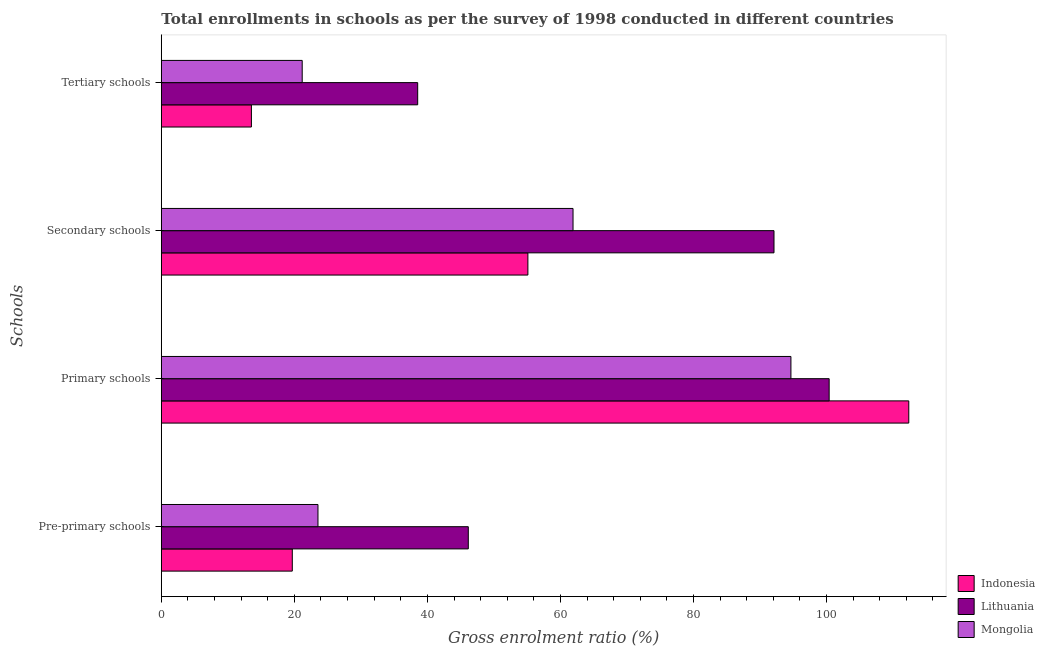How many different coloured bars are there?
Your answer should be compact. 3. How many groups of bars are there?
Your response must be concise. 4. Are the number of bars on each tick of the Y-axis equal?
Give a very brief answer. Yes. What is the label of the 3rd group of bars from the top?
Ensure brevity in your answer.  Primary schools. What is the gross enrolment ratio in primary schools in Mongolia?
Give a very brief answer. 94.65. Across all countries, what is the maximum gross enrolment ratio in secondary schools?
Make the answer very short. 92.11. Across all countries, what is the minimum gross enrolment ratio in secondary schools?
Provide a short and direct response. 55.11. In which country was the gross enrolment ratio in pre-primary schools minimum?
Your answer should be very brief. Indonesia. What is the total gross enrolment ratio in tertiary schools in the graph?
Offer a very short reply. 73.26. What is the difference between the gross enrolment ratio in tertiary schools in Lithuania and that in Indonesia?
Your response must be concise. 25. What is the difference between the gross enrolment ratio in secondary schools in Mongolia and the gross enrolment ratio in primary schools in Lithuania?
Offer a terse response. -38.5. What is the average gross enrolment ratio in primary schools per country?
Your response must be concise. 102.47. What is the difference between the gross enrolment ratio in primary schools and gross enrolment ratio in tertiary schools in Lithuania?
Your answer should be very brief. 61.86. What is the ratio of the gross enrolment ratio in pre-primary schools in Lithuania to that in Indonesia?
Ensure brevity in your answer.  2.34. Is the difference between the gross enrolment ratio in secondary schools in Indonesia and Mongolia greater than the difference between the gross enrolment ratio in pre-primary schools in Indonesia and Mongolia?
Offer a very short reply. No. What is the difference between the highest and the second highest gross enrolment ratio in tertiary schools?
Keep it short and to the point. 17.36. What is the difference between the highest and the lowest gross enrolment ratio in pre-primary schools?
Ensure brevity in your answer.  26.46. In how many countries, is the gross enrolment ratio in tertiary schools greater than the average gross enrolment ratio in tertiary schools taken over all countries?
Provide a short and direct response. 1. Is it the case that in every country, the sum of the gross enrolment ratio in tertiary schools and gross enrolment ratio in pre-primary schools is greater than the sum of gross enrolment ratio in primary schools and gross enrolment ratio in secondary schools?
Keep it short and to the point. No. What does the 2nd bar from the top in Secondary schools represents?
Ensure brevity in your answer.  Lithuania. What does the 2nd bar from the bottom in Secondary schools represents?
Keep it short and to the point. Lithuania. Are all the bars in the graph horizontal?
Ensure brevity in your answer.  Yes. What is the difference between two consecutive major ticks on the X-axis?
Your answer should be compact. 20. Does the graph contain any zero values?
Provide a short and direct response. No. Does the graph contain grids?
Your answer should be very brief. No. What is the title of the graph?
Provide a succinct answer. Total enrollments in schools as per the survey of 1998 conducted in different countries. Does "Middle East & North Africa (all income levels)" appear as one of the legend labels in the graph?
Make the answer very short. No. What is the label or title of the Y-axis?
Your answer should be compact. Schools. What is the Gross enrolment ratio (%) of Indonesia in Pre-primary schools?
Make the answer very short. 19.69. What is the Gross enrolment ratio (%) in Lithuania in Pre-primary schools?
Your answer should be compact. 46.15. What is the Gross enrolment ratio (%) of Mongolia in Pre-primary schools?
Provide a short and direct response. 23.55. What is the Gross enrolment ratio (%) of Indonesia in Primary schools?
Your response must be concise. 112.37. What is the Gross enrolment ratio (%) in Lithuania in Primary schools?
Give a very brief answer. 100.4. What is the Gross enrolment ratio (%) of Mongolia in Primary schools?
Offer a very short reply. 94.65. What is the Gross enrolment ratio (%) of Indonesia in Secondary schools?
Give a very brief answer. 55.11. What is the Gross enrolment ratio (%) of Lithuania in Secondary schools?
Ensure brevity in your answer.  92.11. What is the Gross enrolment ratio (%) in Mongolia in Secondary schools?
Provide a succinct answer. 61.89. What is the Gross enrolment ratio (%) in Indonesia in Tertiary schools?
Your answer should be very brief. 13.54. What is the Gross enrolment ratio (%) of Lithuania in Tertiary schools?
Make the answer very short. 38.54. What is the Gross enrolment ratio (%) in Mongolia in Tertiary schools?
Give a very brief answer. 21.18. Across all Schools, what is the maximum Gross enrolment ratio (%) in Indonesia?
Keep it short and to the point. 112.37. Across all Schools, what is the maximum Gross enrolment ratio (%) in Lithuania?
Provide a short and direct response. 100.4. Across all Schools, what is the maximum Gross enrolment ratio (%) of Mongolia?
Offer a very short reply. 94.65. Across all Schools, what is the minimum Gross enrolment ratio (%) of Indonesia?
Offer a very short reply. 13.54. Across all Schools, what is the minimum Gross enrolment ratio (%) of Lithuania?
Your answer should be very brief. 38.54. Across all Schools, what is the minimum Gross enrolment ratio (%) of Mongolia?
Your answer should be very brief. 21.18. What is the total Gross enrolment ratio (%) of Indonesia in the graph?
Provide a short and direct response. 200.71. What is the total Gross enrolment ratio (%) of Lithuania in the graph?
Give a very brief answer. 277.2. What is the total Gross enrolment ratio (%) of Mongolia in the graph?
Ensure brevity in your answer.  201.27. What is the difference between the Gross enrolment ratio (%) in Indonesia in Pre-primary schools and that in Primary schools?
Offer a very short reply. -92.68. What is the difference between the Gross enrolment ratio (%) in Lithuania in Pre-primary schools and that in Primary schools?
Offer a very short reply. -54.25. What is the difference between the Gross enrolment ratio (%) of Mongolia in Pre-primary schools and that in Primary schools?
Offer a very short reply. -71.1. What is the difference between the Gross enrolment ratio (%) in Indonesia in Pre-primary schools and that in Secondary schools?
Give a very brief answer. -35.42. What is the difference between the Gross enrolment ratio (%) in Lithuania in Pre-primary schools and that in Secondary schools?
Provide a short and direct response. -45.96. What is the difference between the Gross enrolment ratio (%) in Mongolia in Pre-primary schools and that in Secondary schools?
Keep it short and to the point. -38.35. What is the difference between the Gross enrolment ratio (%) in Indonesia in Pre-primary schools and that in Tertiary schools?
Your answer should be compact. 6.15. What is the difference between the Gross enrolment ratio (%) of Lithuania in Pre-primary schools and that in Tertiary schools?
Offer a very short reply. 7.61. What is the difference between the Gross enrolment ratio (%) in Mongolia in Pre-primary schools and that in Tertiary schools?
Your answer should be compact. 2.37. What is the difference between the Gross enrolment ratio (%) of Indonesia in Primary schools and that in Secondary schools?
Provide a succinct answer. 57.26. What is the difference between the Gross enrolment ratio (%) in Lithuania in Primary schools and that in Secondary schools?
Keep it short and to the point. 8.29. What is the difference between the Gross enrolment ratio (%) in Mongolia in Primary schools and that in Secondary schools?
Provide a short and direct response. 32.76. What is the difference between the Gross enrolment ratio (%) in Indonesia in Primary schools and that in Tertiary schools?
Your response must be concise. 98.82. What is the difference between the Gross enrolment ratio (%) in Lithuania in Primary schools and that in Tertiary schools?
Your answer should be very brief. 61.86. What is the difference between the Gross enrolment ratio (%) of Mongolia in Primary schools and that in Tertiary schools?
Ensure brevity in your answer.  73.47. What is the difference between the Gross enrolment ratio (%) in Indonesia in Secondary schools and that in Tertiary schools?
Provide a succinct answer. 41.56. What is the difference between the Gross enrolment ratio (%) in Lithuania in Secondary schools and that in Tertiary schools?
Offer a terse response. 53.56. What is the difference between the Gross enrolment ratio (%) of Mongolia in Secondary schools and that in Tertiary schools?
Offer a terse response. 40.72. What is the difference between the Gross enrolment ratio (%) in Indonesia in Pre-primary schools and the Gross enrolment ratio (%) in Lithuania in Primary schools?
Offer a very short reply. -80.71. What is the difference between the Gross enrolment ratio (%) in Indonesia in Pre-primary schools and the Gross enrolment ratio (%) in Mongolia in Primary schools?
Your answer should be compact. -74.96. What is the difference between the Gross enrolment ratio (%) of Lithuania in Pre-primary schools and the Gross enrolment ratio (%) of Mongolia in Primary schools?
Your response must be concise. -48.5. What is the difference between the Gross enrolment ratio (%) in Indonesia in Pre-primary schools and the Gross enrolment ratio (%) in Lithuania in Secondary schools?
Offer a terse response. -72.42. What is the difference between the Gross enrolment ratio (%) of Indonesia in Pre-primary schools and the Gross enrolment ratio (%) of Mongolia in Secondary schools?
Your response must be concise. -42.2. What is the difference between the Gross enrolment ratio (%) in Lithuania in Pre-primary schools and the Gross enrolment ratio (%) in Mongolia in Secondary schools?
Offer a very short reply. -15.74. What is the difference between the Gross enrolment ratio (%) of Indonesia in Pre-primary schools and the Gross enrolment ratio (%) of Lithuania in Tertiary schools?
Ensure brevity in your answer.  -18.85. What is the difference between the Gross enrolment ratio (%) in Indonesia in Pre-primary schools and the Gross enrolment ratio (%) in Mongolia in Tertiary schools?
Give a very brief answer. -1.49. What is the difference between the Gross enrolment ratio (%) of Lithuania in Pre-primary schools and the Gross enrolment ratio (%) of Mongolia in Tertiary schools?
Provide a succinct answer. 24.97. What is the difference between the Gross enrolment ratio (%) of Indonesia in Primary schools and the Gross enrolment ratio (%) of Lithuania in Secondary schools?
Give a very brief answer. 20.26. What is the difference between the Gross enrolment ratio (%) in Indonesia in Primary schools and the Gross enrolment ratio (%) in Mongolia in Secondary schools?
Ensure brevity in your answer.  50.47. What is the difference between the Gross enrolment ratio (%) in Lithuania in Primary schools and the Gross enrolment ratio (%) in Mongolia in Secondary schools?
Give a very brief answer. 38.5. What is the difference between the Gross enrolment ratio (%) of Indonesia in Primary schools and the Gross enrolment ratio (%) of Lithuania in Tertiary schools?
Offer a very short reply. 73.83. What is the difference between the Gross enrolment ratio (%) in Indonesia in Primary schools and the Gross enrolment ratio (%) in Mongolia in Tertiary schools?
Give a very brief answer. 91.19. What is the difference between the Gross enrolment ratio (%) in Lithuania in Primary schools and the Gross enrolment ratio (%) in Mongolia in Tertiary schools?
Your response must be concise. 79.22. What is the difference between the Gross enrolment ratio (%) in Indonesia in Secondary schools and the Gross enrolment ratio (%) in Lithuania in Tertiary schools?
Provide a short and direct response. 16.57. What is the difference between the Gross enrolment ratio (%) in Indonesia in Secondary schools and the Gross enrolment ratio (%) in Mongolia in Tertiary schools?
Your answer should be very brief. 33.93. What is the difference between the Gross enrolment ratio (%) of Lithuania in Secondary schools and the Gross enrolment ratio (%) of Mongolia in Tertiary schools?
Offer a terse response. 70.93. What is the average Gross enrolment ratio (%) in Indonesia per Schools?
Keep it short and to the point. 50.18. What is the average Gross enrolment ratio (%) of Lithuania per Schools?
Provide a short and direct response. 69.3. What is the average Gross enrolment ratio (%) of Mongolia per Schools?
Offer a very short reply. 50.32. What is the difference between the Gross enrolment ratio (%) in Indonesia and Gross enrolment ratio (%) in Lithuania in Pre-primary schools?
Make the answer very short. -26.46. What is the difference between the Gross enrolment ratio (%) in Indonesia and Gross enrolment ratio (%) in Mongolia in Pre-primary schools?
Ensure brevity in your answer.  -3.86. What is the difference between the Gross enrolment ratio (%) in Lithuania and Gross enrolment ratio (%) in Mongolia in Pre-primary schools?
Your answer should be compact. 22.6. What is the difference between the Gross enrolment ratio (%) in Indonesia and Gross enrolment ratio (%) in Lithuania in Primary schools?
Give a very brief answer. 11.97. What is the difference between the Gross enrolment ratio (%) of Indonesia and Gross enrolment ratio (%) of Mongolia in Primary schools?
Provide a succinct answer. 17.72. What is the difference between the Gross enrolment ratio (%) in Lithuania and Gross enrolment ratio (%) in Mongolia in Primary schools?
Give a very brief answer. 5.75. What is the difference between the Gross enrolment ratio (%) of Indonesia and Gross enrolment ratio (%) of Lithuania in Secondary schools?
Offer a terse response. -37. What is the difference between the Gross enrolment ratio (%) in Indonesia and Gross enrolment ratio (%) in Mongolia in Secondary schools?
Offer a terse response. -6.79. What is the difference between the Gross enrolment ratio (%) of Lithuania and Gross enrolment ratio (%) of Mongolia in Secondary schools?
Ensure brevity in your answer.  30.21. What is the difference between the Gross enrolment ratio (%) of Indonesia and Gross enrolment ratio (%) of Lithuania in Tertiary schools?
Make the answer very short. -25. What is the difference between the Gross enrolment ratio (%) of Indonesia and Gross enrolment ratio (%) of Mongolia in Tertiary schools?
Offer a very short reply. -7.64. What is the difference between the Gross enrolment ratio (%) in Lithuania and Gross enrolment ratio (%) in Mongolia in Tertiary schools?
Give a very brief answer. 17.36. What is the ratio of the Gross enrolment ratio (%) in Indonesia in Pre-primary schools to that in Primary schools?
Offer a very short reply. 0.18. What is the ratio of the Gross enrolment ratio (%) of Lithuania in Pre-primary schools to that in Primary schools?
Your answer should be compact. 0.46. What is the ratio of the Gross enrolment ratio (%) in Mongolia in Pre-primary schools to that in Primary schools?
Offer a very short reply. 0.25. What is the ratio of the Gross enrolment ratio (%) in Indonesia in Pre-primary schools to that in Secondary schools?
Make the answer very short. 0.36. What is the ratio of the Gross enrolment ratio (%) in Lithuania in Pre-primary schools to that in Secondary schools?
Your response must be concise. 0.5. What is the ratio of the Gross enrolment ratio (%) of Mongolia in Pre-primary schools to that in Secondary schools?
Give a very brief answer. 0.38. What is the ratio of the Gross enrolment ratio (%) in Indonesia in Pre-primary schools to that in Tertiary schools?
Make the answer very short. 1.45. What is the ratio of the Gross enrolment ratio (%) in Lithuania in Pre-primary schools to that in Tertiary schools?
Your answer should be compact. 1.2. What is the ratio of the Gross enrolment ratio (%) in Mongolia in Pre-primary schools to that in Tertiary schools?
Keep it short and to the point. 1.11. What is the ratio of the Gross enrolment ratio (%) in Indonesia in Primary schools to that in Secondary schools?
Keep it short and to the point. 2.04. What is the ratio of the Gross enrolment ratio (%) of Lithuania in Primary schools to that in Secondary schools?
Provide a short and direct response. 1.09. What is the ratio of the Gross enrolment ratio (%) in Mongolia in Primary schools to that in Secondary schools?
Your answer should be compact. 1.53. What is the ratio of the Gross enrolment ratio (%) of Indonesia in Primary schools to that in Tertiary schools?
Give a very brief answer. 8.3. What is the ratio of the Gross enrolment ratio (%) of Lithuania in Primary schools to that in Tertiary schools?
Offer a terse response. 2.6. What is the ratio of the Gross enrolment ratio (%) of Mongolia in Primary schools to that in Tertiary schools?
Give a very brief answer. 4.47. What is the ratio of the Gross enrolment ratio (%) of Indonesia in Secondary schools to that in Tertiary schools?
Your answer should be very brief. 4.07. What is the ratio of the Gross enrolment ratio (%) in Lithuania in Secondary schools to that in Tertiary schools?
Keep it short and to the point. 2.39. What is the ratio of the Gross enrolment ratio (%) in Mongolia in Secondary schools to that in Tertiary schools?
Your answer should be very brief. 2.92. What is the difference between the highest and the second highest Gross enrolment ratio (%) in Indonesia?
Offer a terse response. 57.26. What is the difference between the highest and the second highest Gross enrolment ratio (%) in Lithuania?
Offer a terse response. 8.29. What is the difference between the highest and the second highest Gross enrolment ratio (%) in Mongolia?
Give a very brief answer. 32.76. What is the difference between the highest and the lowest Gross enrolment ratio (%) in Indonesia?
Give a very brief answer. 98.82. What is the difference between the highest and the lowest Gross enrolment ratio (%) of Lithuania?
Your answer should be very brief. 61.86. What is the difference between the highest and the lowest Gross enrolment ratio (%) in Mongolia?
Keep it short and to the point. 73.47. 